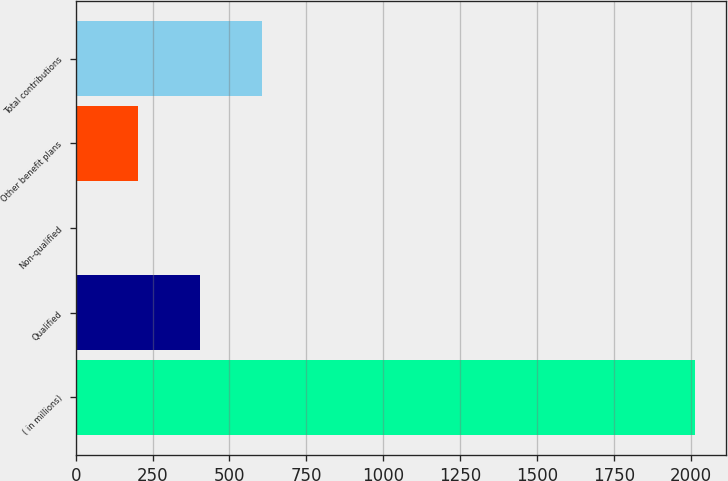<chart> <loc_0><loc_0><loc_500><loc_500><bar_chart><fcel>( in millions)<fcel>Qualified<fcel>Non-qualified<fcel>Other benefit plans<fcel>Total contributions<nl><fcel>2014<fcel>405.2<fcel>3<fcel>204.1<fcel>606.3<nl></chart> 